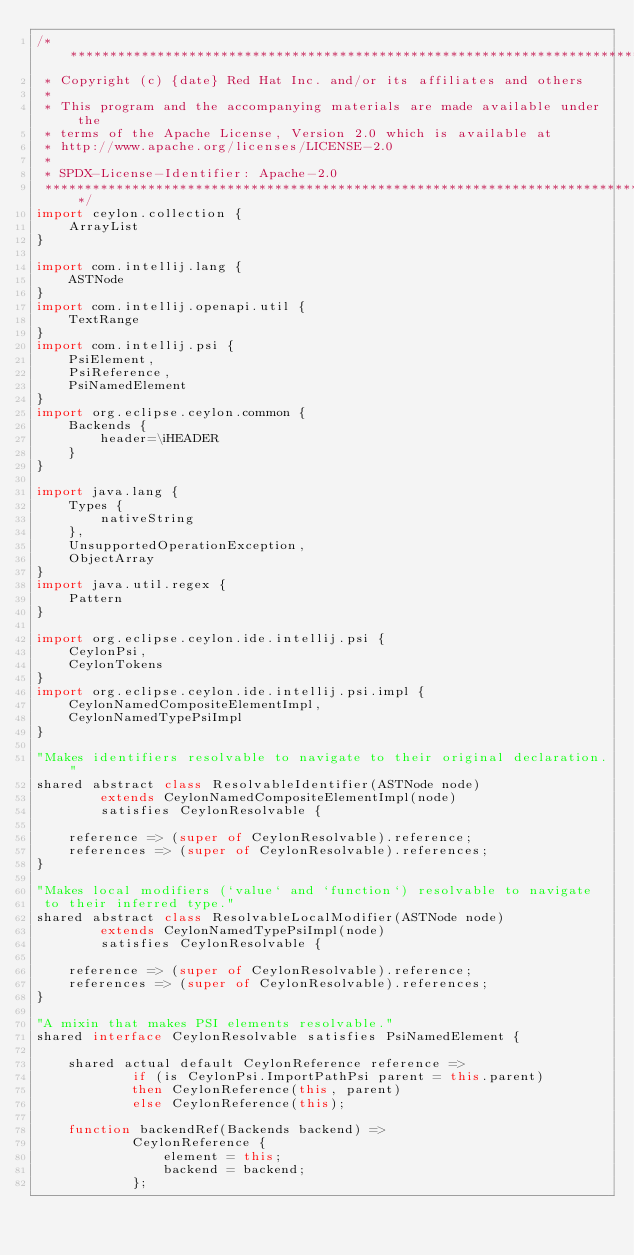Convert code to text. <code><loc_0><loc_0><loc_500><loc_500><_Ceylon_>/********************************************************************************
 * Copyright (c) {date} Red Hat Inc. and/or its affiliates and others
 *
 * This program and the accompanying materials are made available under the 
 * terms of the Apache License, Version 2.0 which is available at
 * http://www.apache.org/licenses/LICENSE-2.0
 *
 * SPDX-License-Identifier: Apache-2.0 
 ********************************************************************************/
import ceylon.collection {
    ArrayList
}

import com.intellij.lang {
    ASTNode
}
import com.intellij.openapi.util {
    TextRange
}
import com.intellij.psi {
    PsiElement,
    PsiReference,
    PsiNamedElement
}
import org.eclipse.ceylon.common {
    Backends {
        header=\iHEADER
    }
}

import java.lang {
    Types {
        nativeString
    },
    UnsupportedOperationException,
    ObjectArray
}
import java.util.regex {
    Pattern
}

import org.eclipse.ceylon.ide.intellij.psi {
    CeylonPsi,
    CeylonTokens
}
import org.eclipse.ceylon.ide.intellij.psi.impl {
    CeylonNamedCompositeElementImpl,
    CeylonNamedTypePsiImpl
}

"Makes identifiers resolvable to navigate to their original declaration."
shared abstract class ResolvableIdentifier(ASTNode node)
        extends CeylonNamedCompositeElementImpl(node)
        satisfies CeylonResolvable {

    reference => (super of CeylonResolvable).reference;
    references => (super of CeylonResolvable).references;
}

"Makes local modifiers (`value` and `function`) resolvable to navigate
 to their inferred type."
shared abstract class ResolvableLocalModifier(ASTNode node)
        extends CeylonNamedTypePsiImpl(node)
        satisfies CeylonResolvable {

    reference => (super of CeylonResolvable).reference;
    references => (super of CeylonResolvable).references;
}

"A mixin that makes PSI elements resolvable."
shared interface CeylonResolvable satisfies PsiNamedElement {

    shared actual default CeylonReference reference =>
            if (is CeylonPsi.ImportPathPsi parent = this.parent)
            then CeylonReference(this, parent)
            else CeylonReference(this);

    function backendRef(Backends backend) =>
            CeylonReference {
                element = this;
                backend = backend;
            };
</code> 